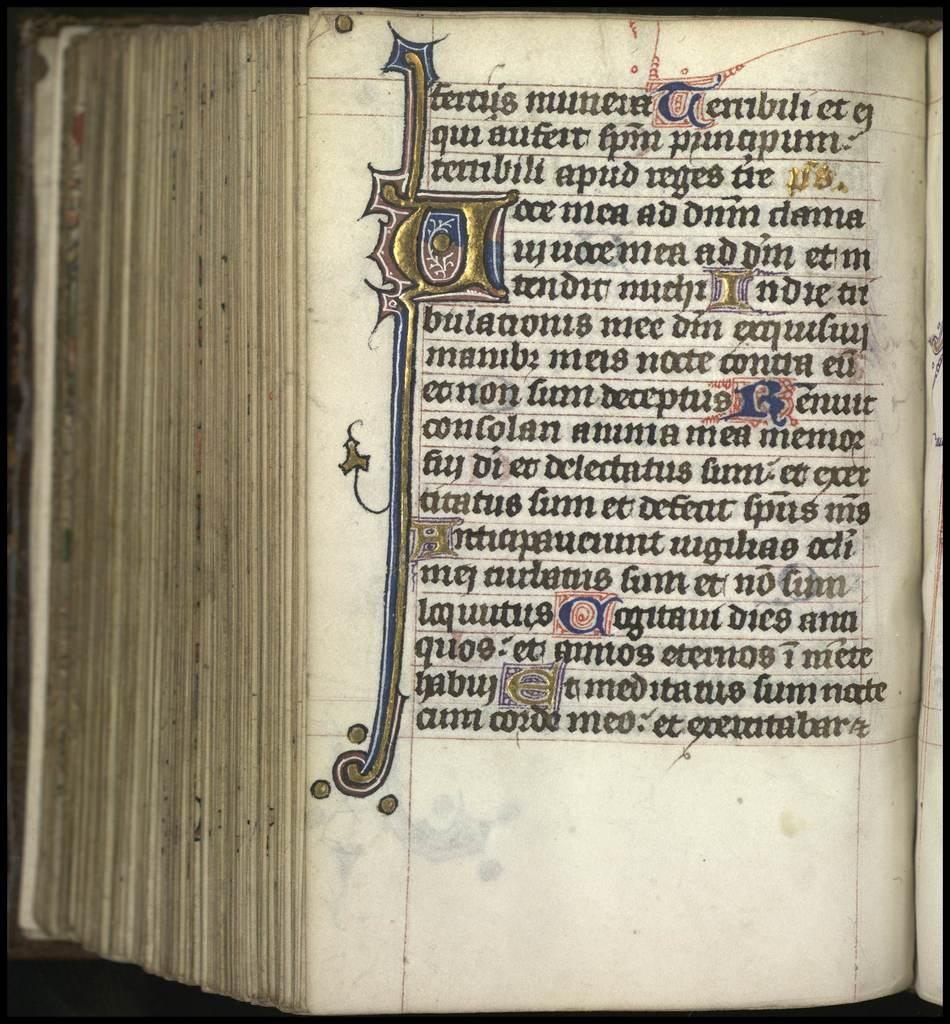What object can be seen in the image? There is a book in the image. What is visible on the pages of the book? There are texts written on a page in the book. Where is the box located in the image? There is no box present in the image. What type of market can be seen in the background of the image? There is no market visible in the image; it only features a book with text on a page. 